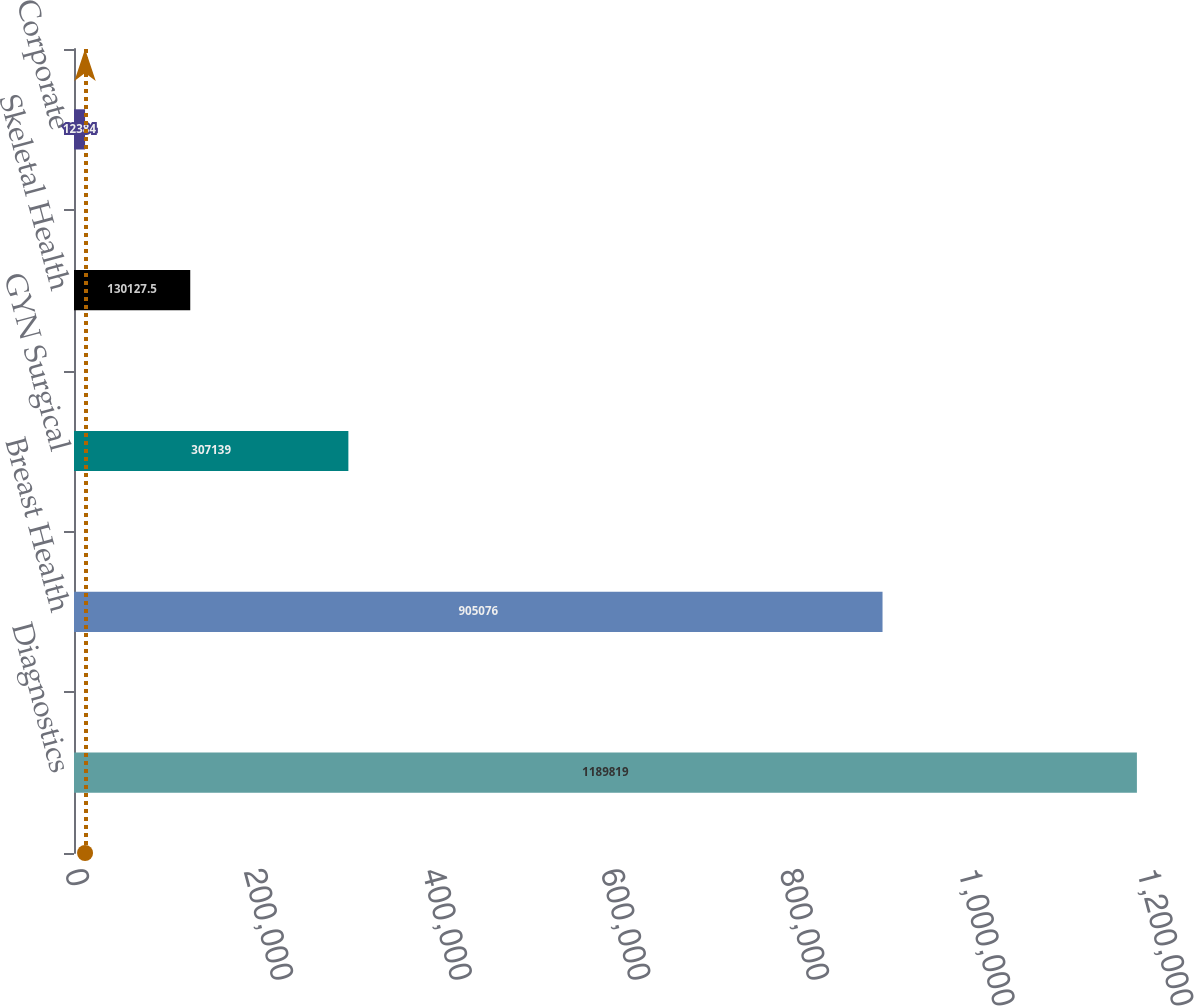Convert chart. <chart><loc_0><loc_0><loc_500><loc_500><bar_chart><fcel>Diagnostics<fcel>Breast Health<fcel>GYN Surgical<fcel>Skeletal Health<fcel>Corporate<nl><fcel>1.18982e+06<fcel>905076<fcel>307139<fcel>130128<fcel>12384<nl></chart> 